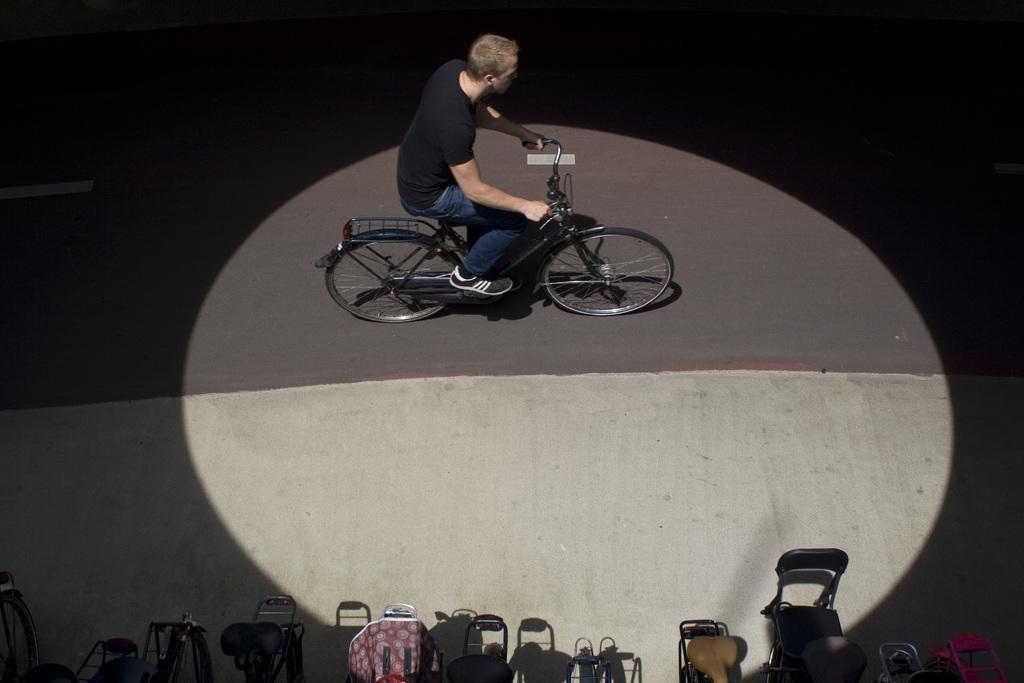Who is present in the image? There is a man in the image. What is the man doing in the image? The man is on a cycle. How many cycles can be seen in the image? There are multiple cycles in the image. What is the setting of the image? There is a path visible in the image. What is the lighting condition in the image? The image appears to be dark. Can you see any poisonous plants near the ocean in the image? There is no ocean or poisonous plants present in the image. How many planes are flying above the man on the cycle? There are no planes visible in the image. 